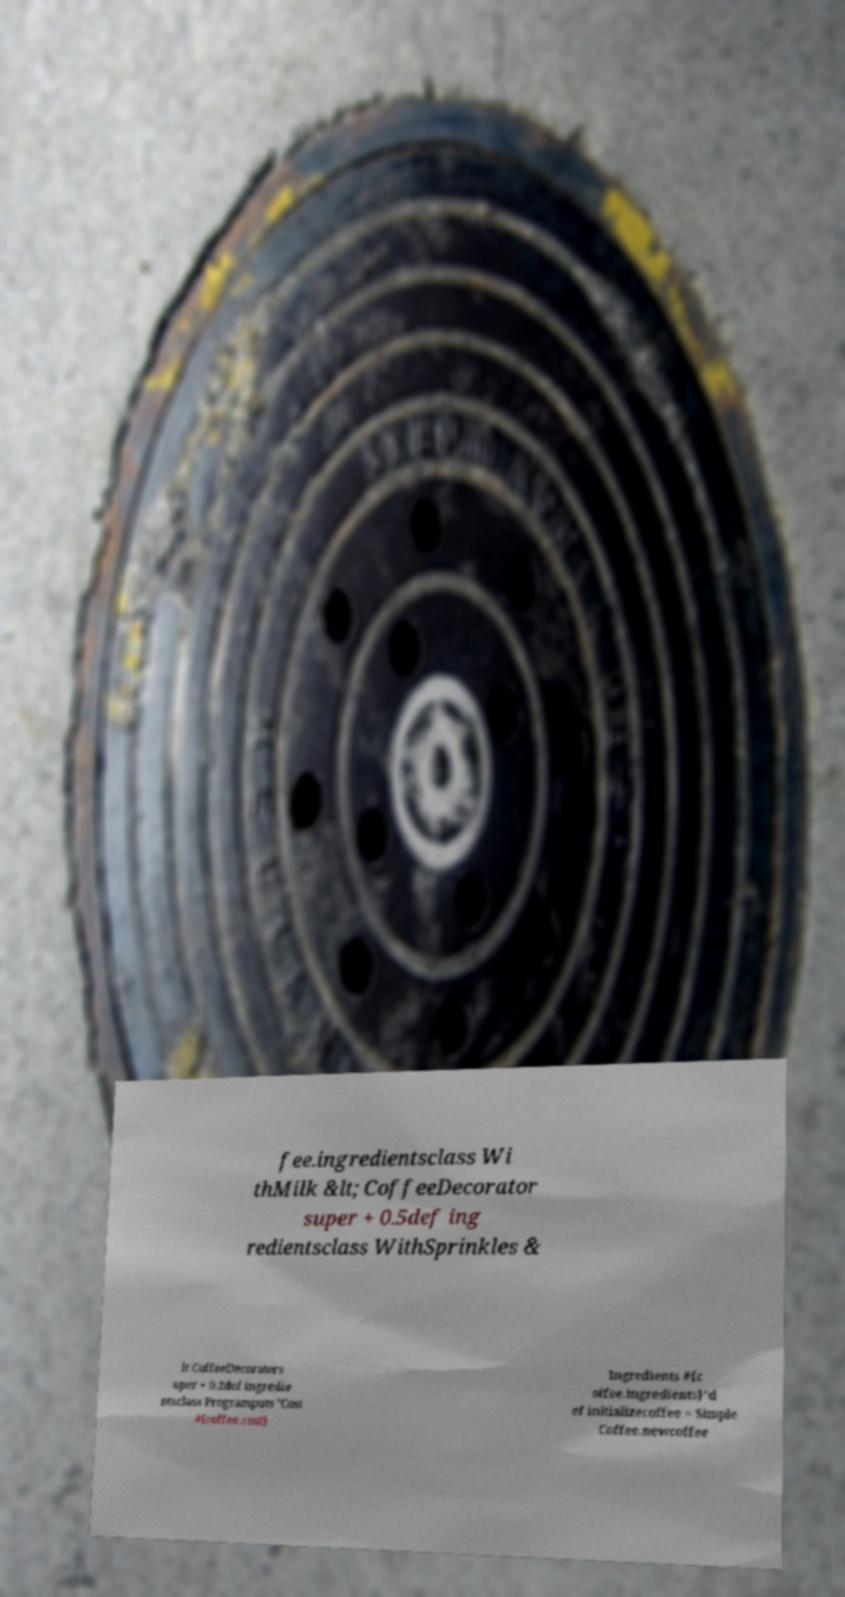Could you extract and type out the text from this image? fee.ingredientsclass Wi thMilk &lt; CoffeeDecorator super + 0.5def ing redientsclass WithSprinkles & lt CoffeeDecorators uper + 0.2def ingredie ntsclass Programputs "Cost #{coffee.cost} Ingredients #{c offee.ingredients}"d ef initializecoffee = Simple Coffee.newcoffee 